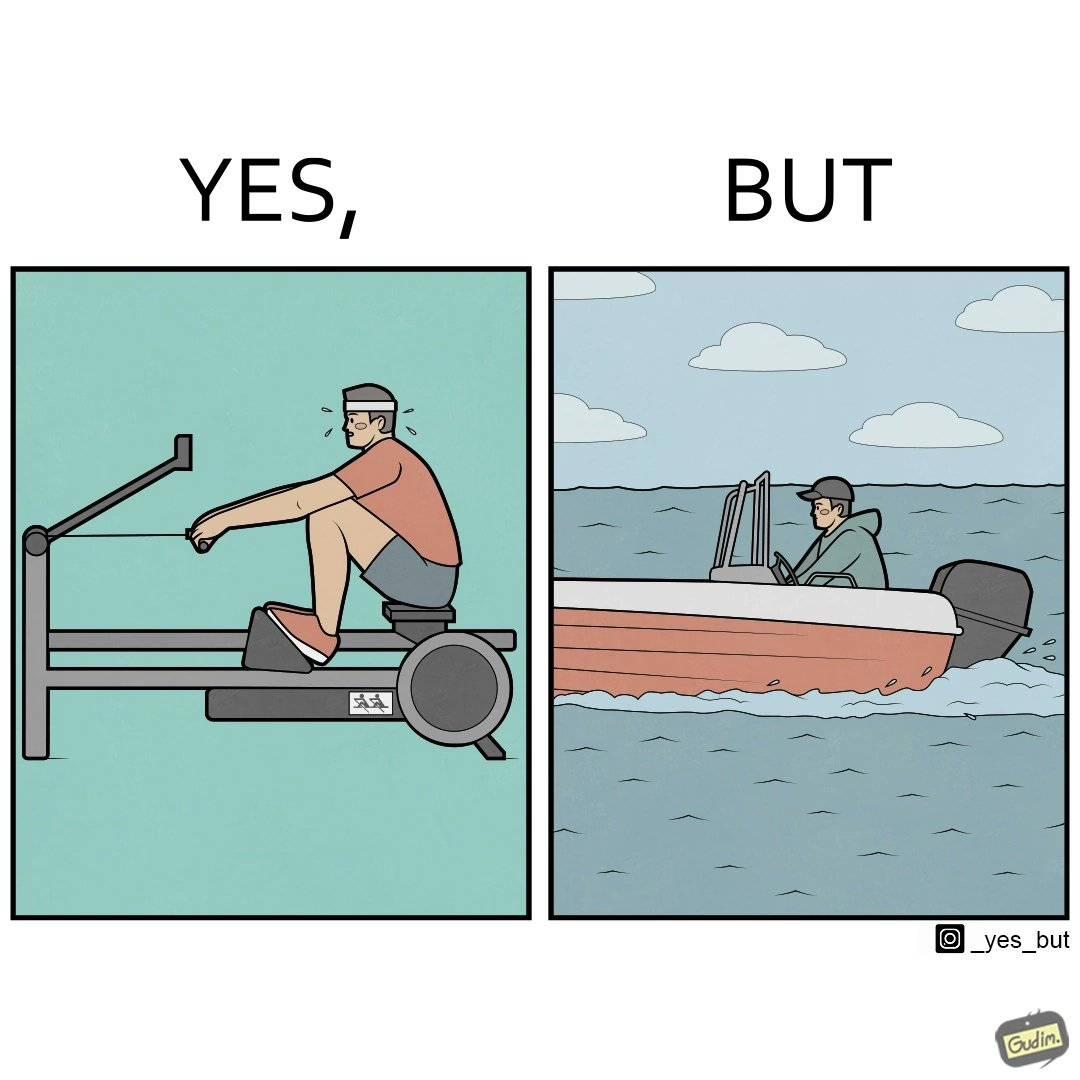What does this image depict? The image is ironic, because people often use rowing machine at the gym don't prefer rowing when it comes to boats 